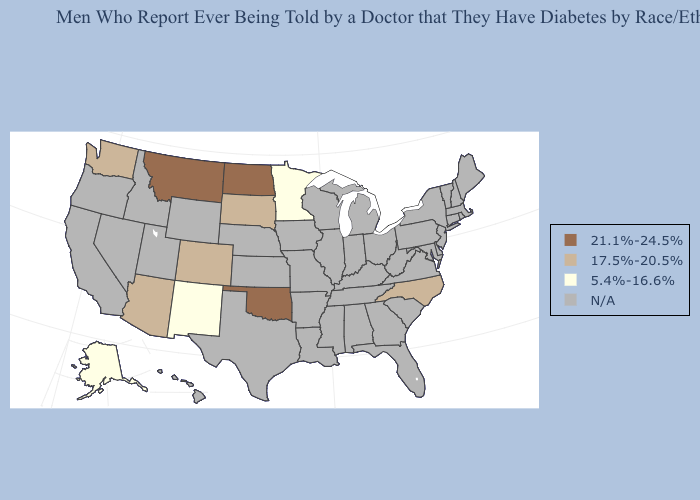Which states have the lowest value in the West?
Concise answer only. Alaska, New Mexico. What is the lowest value in the South?
Short answer required. 17.5%-20.5%. Name the states that have a value in the range N/A?
Be succinct. Alabama, Arkansas, California, Connecticut, Delaware, Florida, Georgia, Hawaii, Idaho, Illinois, Indiana, Iowa, Kansas, Kentucky, Louisiana, Maine, Maryland, Massachusetts, Michigan, Mississippi, Missouri, Nebraska, Nevada, New Hampshire, New Jersey, New York, Ohio, Oregon, Pennsylvania, Rhode Island, South Carolina, Tennessee, Texas, Utah, Vermont, Virginia, West Virginia, Wisconsin, Wyoming. Among the states that border Idaho , does Montana have the highest value?
Short answer required. Yes. Does Arizona have the lowest value in the USA?
Write a very short answer. No. Name the states that have a value in the range 17.5%-20.5%?
Answer briefly. Arizona, Colorado, North Carolina, South Dakota, Washington. Name the states that have a value in the range N/A?
Write a very short answer. Alabama, Arkansas, California, Connecticut, Delaware, Florida, Georgia, Hawaii, Idaho, Illinois, Indiana, Iowa, Kansas, Kentucky, Louisiana, Maine, Maryland, Massachusetts, Michigan, Mississippi, Missouri, Nebraska, Nevada, New Hampshire, New Jersey, New York, Ohio, Oregon, Pennsylvania, Rhode Island, South Carolina, Tennessee, Texas, Utah, Vermont, Virginia, West Virginia, Wisconsin, Wyoming. What is the value of Massachusetts?
Give a very brief answer. N/A. What is the value of Michigan?
Quick response, please. N/A. Is the legend a continuous bar?
Write a very short answer. No. Name the states that have a value in the range 21.1%-24.5%?
Concise answer only. Montana, North Dakota, Oklahoma. 